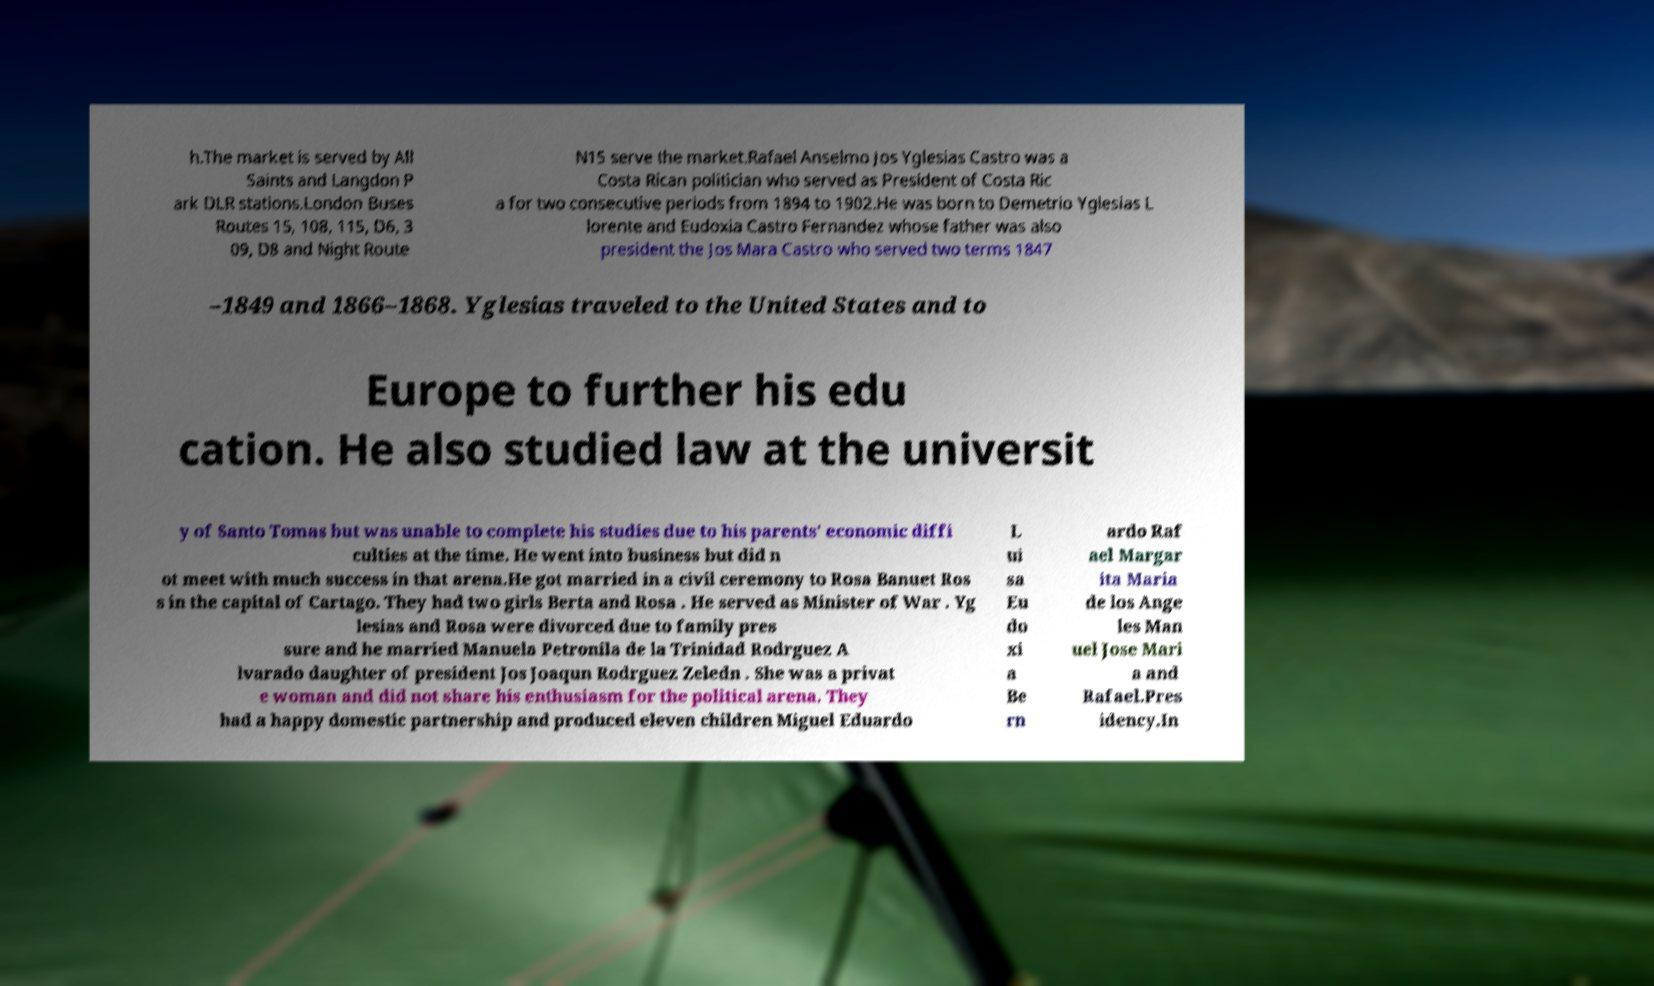Please identify and transcribe the text found in this image. h.The market is served by All Saints and Langdon P ark DLR stations.London Buses Routes 15, 108, 115, D6, 3 09, D8 and Night Route N15 serve the market.Rafael Anselmo Jos Yglesias Castro was a Costa Rican politician who served as President of Costa Ric a for two consecutive periods from 1894 to 1902.He was born to Demetrio Yglesias L lorente and Eudoxia Castro Fernandez whose father was also president the Jos Mara Castro who served two terms 1847 –1849 and 1866–1868. Yglesias traveled to the United States and to Europe to further his edu cation. He also studied law at the universit y of Santo Tomas but was unable to complete his studies due to his parents' economic diffi culties at the time. He went into business but did n ot meet with much success in that arena.He got married in a civil ceremony to Rosa Banuet Ros s in the capital of Cartago. They had two girls Berta and Rosa . He served as Minister of War . Yg lesias and Rosa were divorced due to family pres sure and he married Manuela Petronila de la Trinidad Rodrguez A lvarado daughter of president Jos Joaqun Rodrguez Zeledn . She was a privat e woman and did not share his enthusiasm for the political arena. They had a happy domestic partnership and produced eleven children Miguel Eduardo L ui sa Eu do xi a Be rn ardo Raf ael Margar ita Maria de los Ange les Man uel Jose Mari a and Rafael.Pres idency.In 